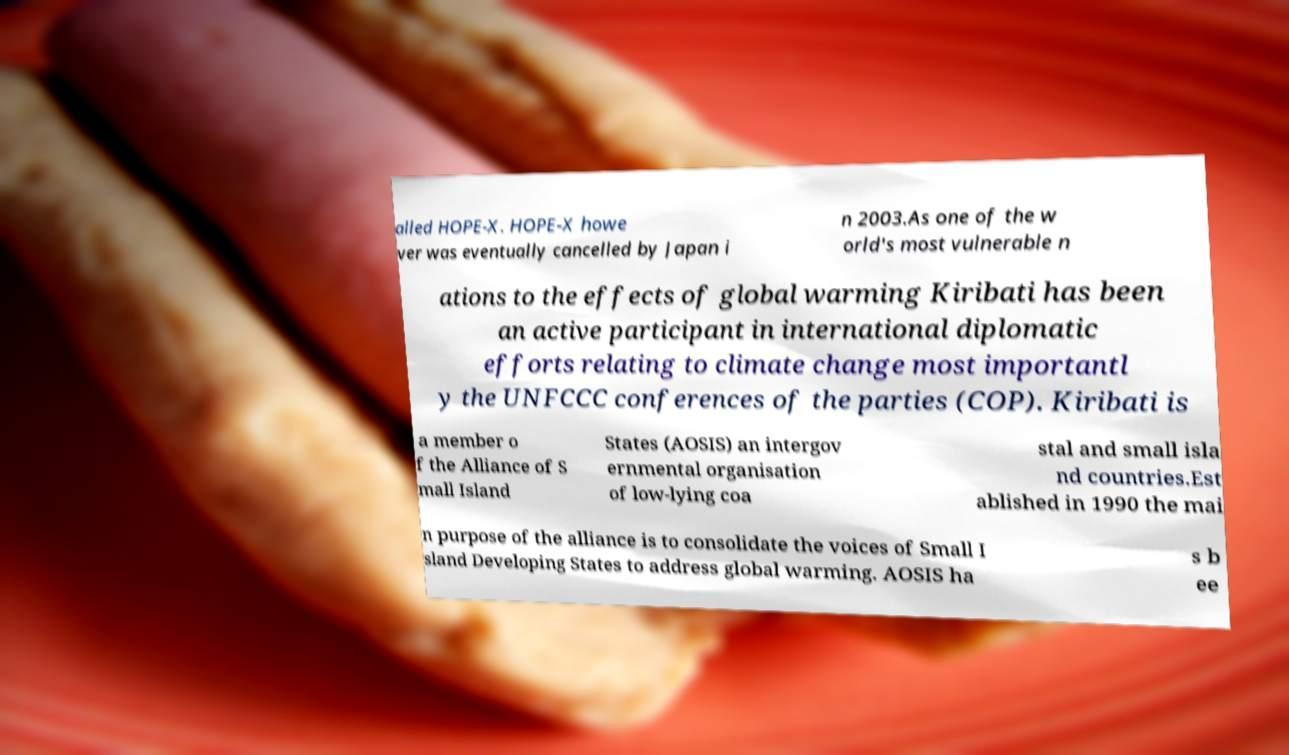Could you extract and type out the text from this image? alled HOPE-X. HOPE-X howe ver was eventually cancelled by Japan i n 2003.As one of the w orld's most vulnerable n ations to the effects of global warming Kiribati has been an active participant in international diplomatic efforts relating to climate change most importantl y the UNFCCC conferences of the parties (COP). Kiribati is a member o f the Alliance of S mall Island States (AOSIS) an intergov ernmental organisation of low-lying coa stal and small isla nd countries.Est ablished in 1990 the mai n purpose of the alliance is to consolidate the voices of Small I sland Developing States to address global warming. AOSIS ha s b ee 